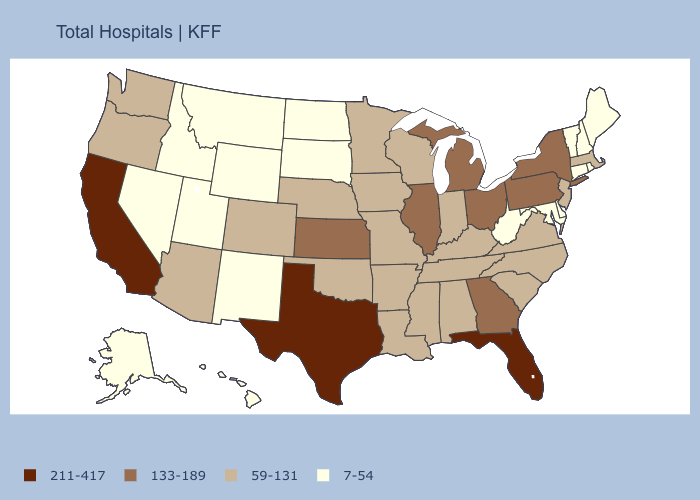Does Missouri have a lower value than Wisconsin?
Give a very brief answer. No. How many symbols are there in the legend?
Give a very brief answer. 4. Does Connecticut have the same value as Kentucky?
Quick response, please. No. Among the states that border Arkansas , which have the lowest value?
Quick response, please. Louisiana, Mississippi, Missouri, Oklahoma, Tennessee. Which states have the highest value in the USA?
Be succinct. California, Florida, Texas. How many symbols are there in the legend?
Quick response, please. 4. Does Virginia have a higher value than New Mexico?
Concise answer only. Yes. Name the states that have a value in the range 211-417?
Short answer required. California, Florida, Texas. Name the states that have a value in the range 133-189?
Quick response, please. Georgia, Illinois, Kansas, Michigan, New York, Ohio, Pennsylvania. Among the states that border Pennsylvania , which have the highest value?
Concise answer only. New York, Ohio. What is the value of South Carolina?
Short answer required. 59-131. Among the states that border Connecticut , which have the lowest value?
Give a very brief answer. Rhode Island. What is the value of Nevada?
Be succinct. 7-54. Among the states that border Texas , does Arkansas have the highest value?
Write a very short answer. Yes. Which states have the highest value in the USA?
Be succinct. California, Florida, Texas. 